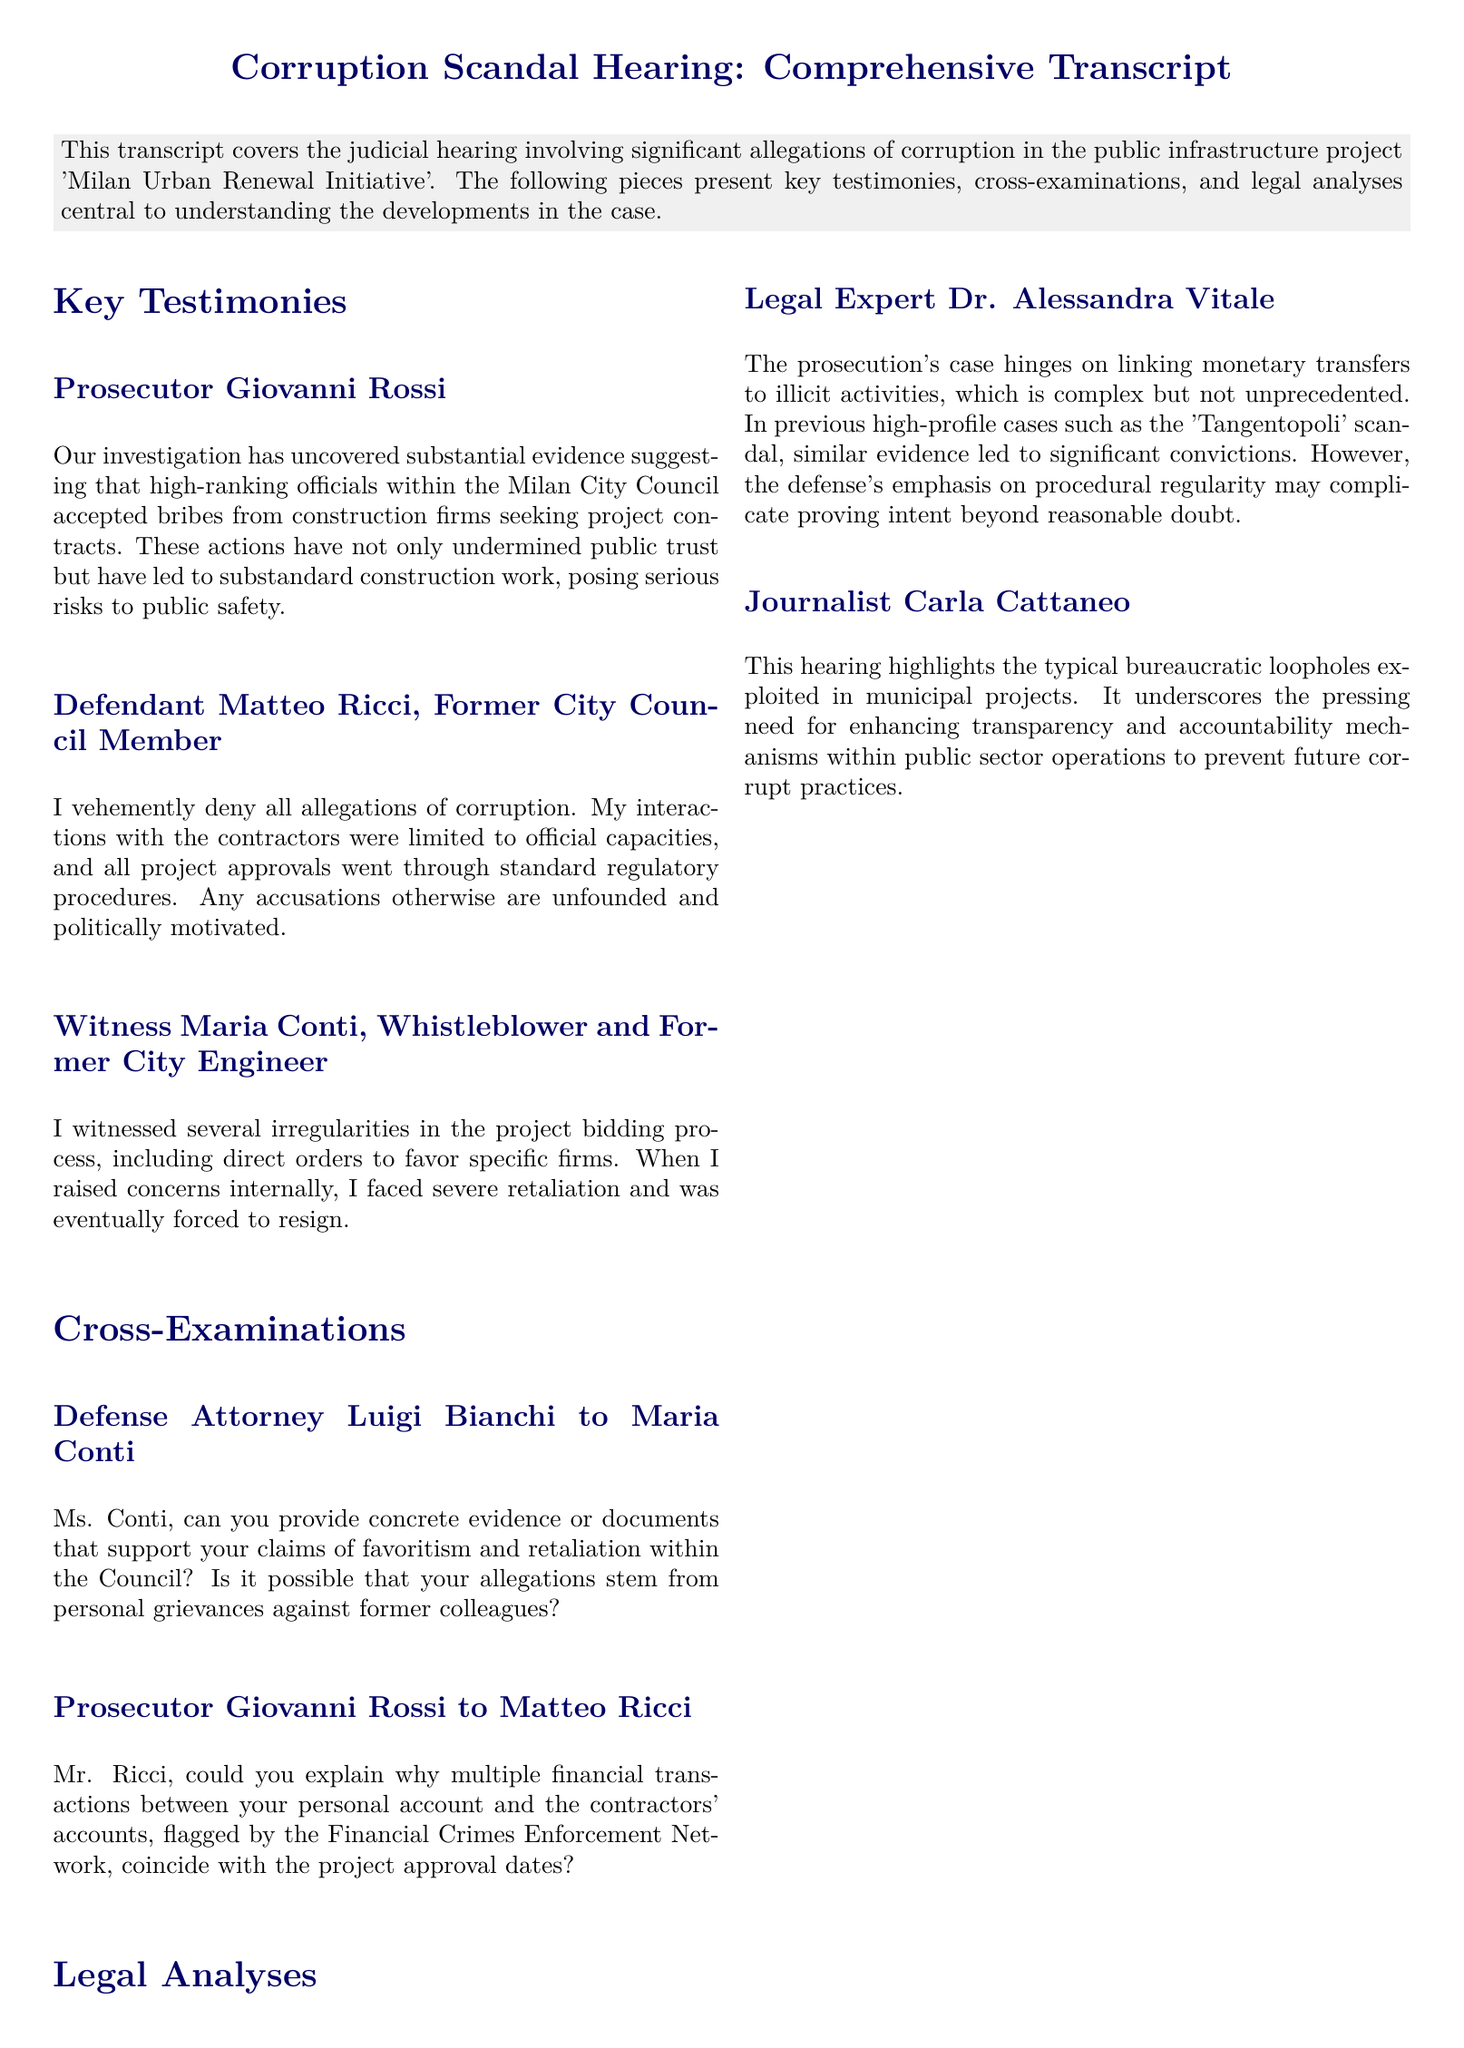What is the name of the public infrastructure project involved in the corruption allegations? The project is referred to as the 'Milan Urban Renewal Initiative' in the document.
Answer: 'Milan Urban Renewal Initiative' Who is the prosecutor in the hearing? The prosecutor's name, mentioned in the document, is Giovanni Rossi.
Answer: Giovanni Rossi What role did Maria Conti hold before becoming a whistleblower? The document states that Maria Conti was a former City Engineer prior to her whistleblower actions.
Answer: Former City Engineer What was the defense attorney's name in the cross-examination? The name of the defense attorney conducting the cross-examination is Luigi Bianchi according to the document.
Answer: Luigi Bianchi How did Matteo Ricci respond to the corruption allegations? Matteo Ricci denied the allegations, claiming they were unfounded and politically motivated.
Answer: Denied What complex issue does Dr. Alessandra Vitale identify in the prosecution's case? Dr. Vitale notes that linking monetary transfers to illicit activities is a complex issue in the prosecution's case.
Answer: Linking monetary transfers What major scandal does Dr. Alessandra Vitale reference as precedent? The document refers to the 'Tangentopoli' scandal as a previous case related to the current hearing.
Answer: Tangentopoli What does journalist Carla Cattaneo emphasize the need for? Carla Cattaneo emphasizes the need for enhancing transparency and accountability mechanisms in public sector operations.
Answer: Transparency and accountability What was the consequence faced by Maria Conti after raising concerns? Maria Conti faced severe retaliation and was forced to resign after raising her concerns, as stated in the document.
Answer: Forced to resign 